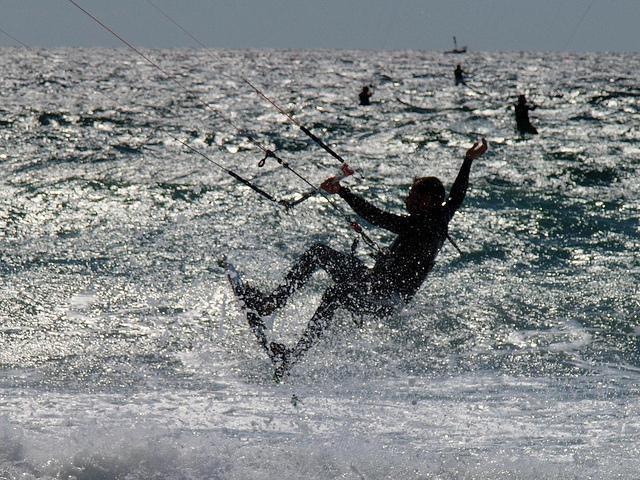How many people are in the water?
Give a very brief answer. 4. 